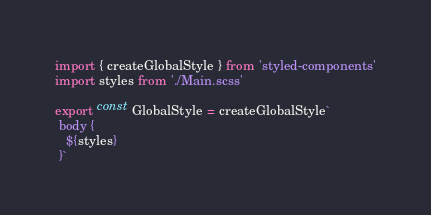Convert code to text. <code><loc_0><loc_0><loc_500><loc_500><_JavaScript_>import { createGlobalStyle } from 'styled-components'
import styles from './Main.scss'

export const GlobalStyle = createGlobalStyle`
 body {
   ${styles}
 }`
</code> 